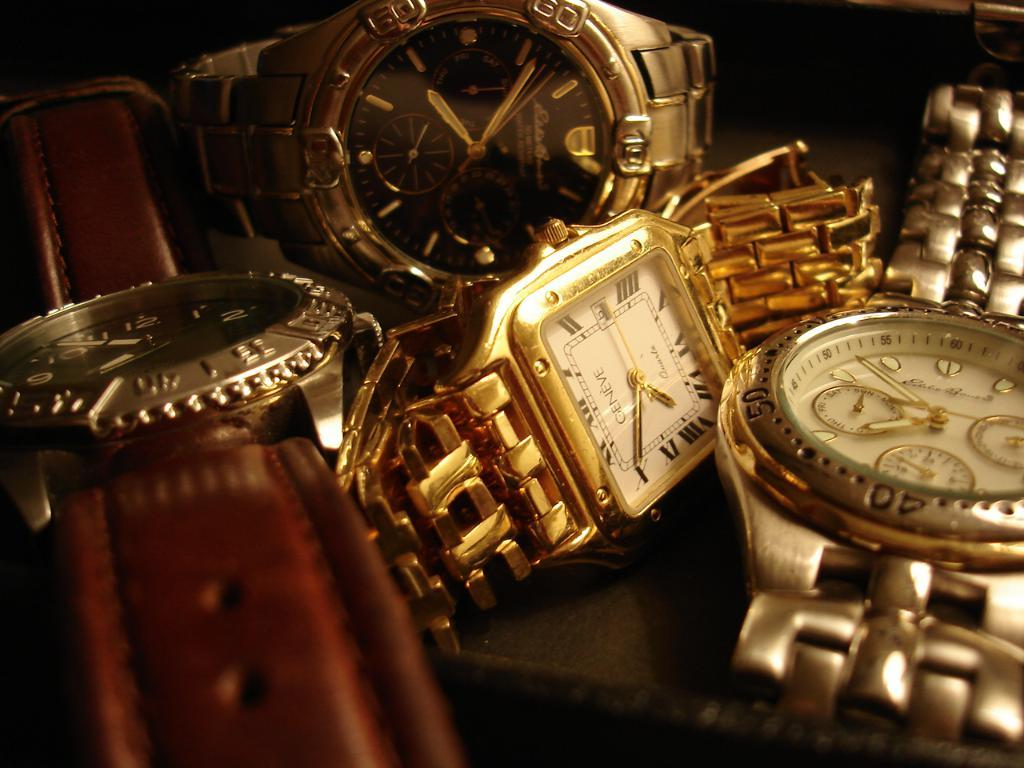<image>
Summarize the visual content of the image. a group of gold watches, one of which says GENEVE on it. 